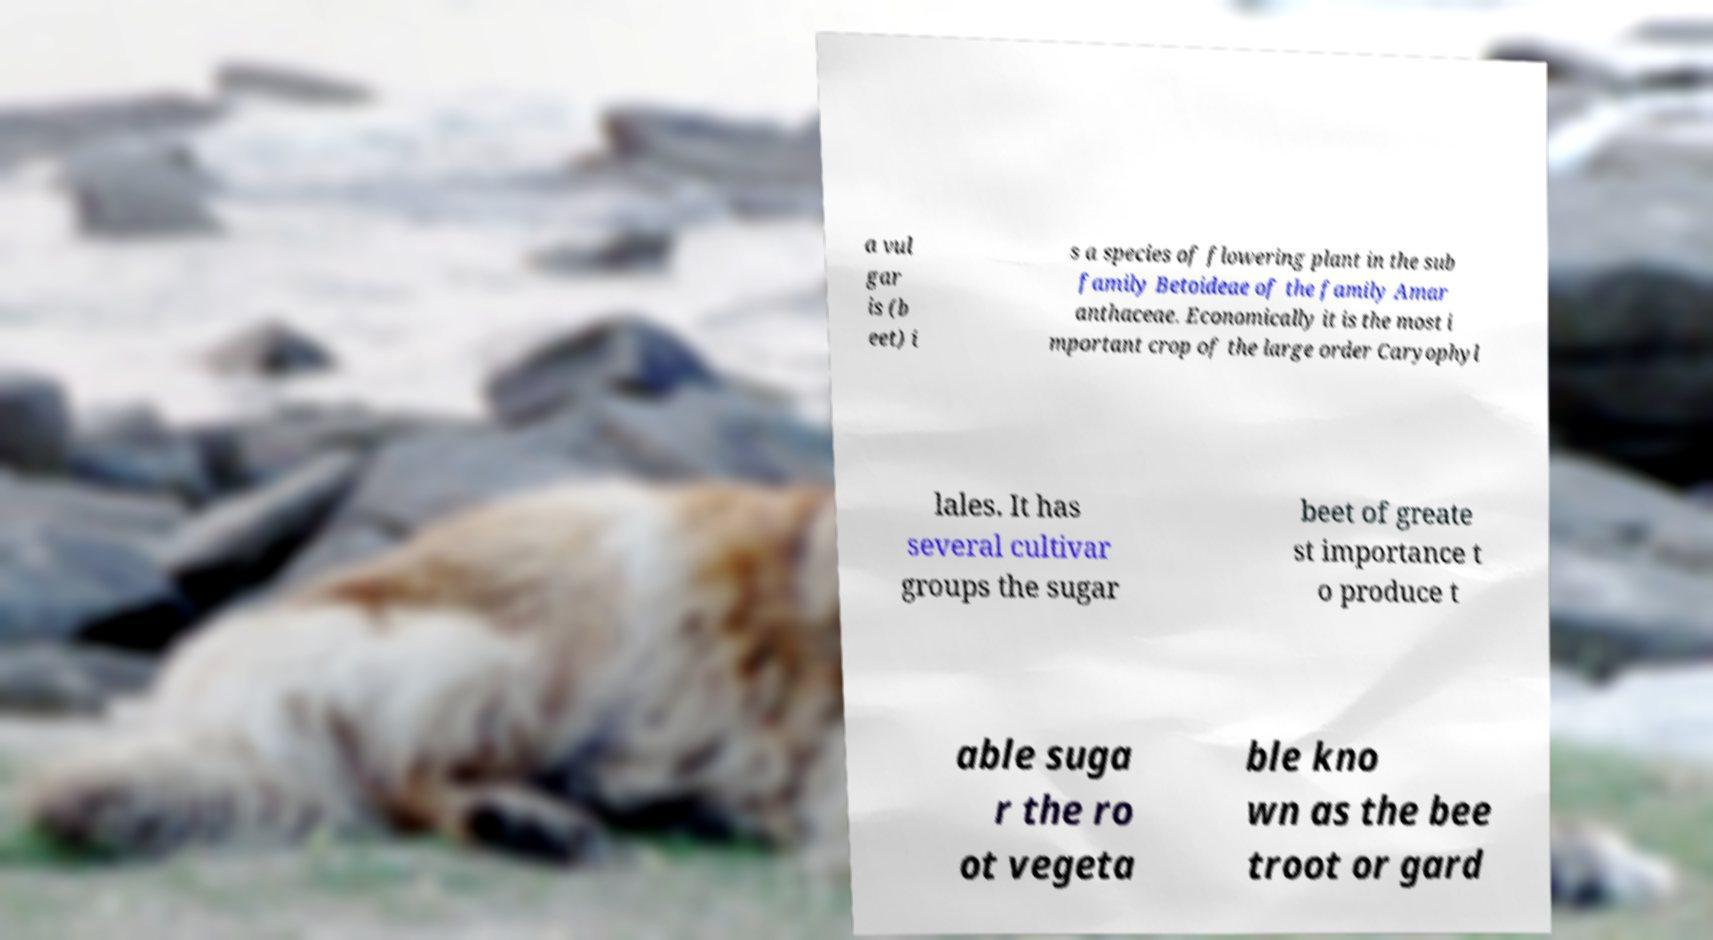There's text embedded in this image that I need extracted. Can you transcribe it verbatim? a vul gar is (b eet) i s a species of flowering plant in the sub family Betoideae of the family Amar anthaceae. Economically it is the most i mportant crop of the large order Caryophyl lales. It has several cultivar groups the sugar beet of greate st importance t o produce t able suga r the ro ot vegeta ble kno wn as the bee troot or gard 